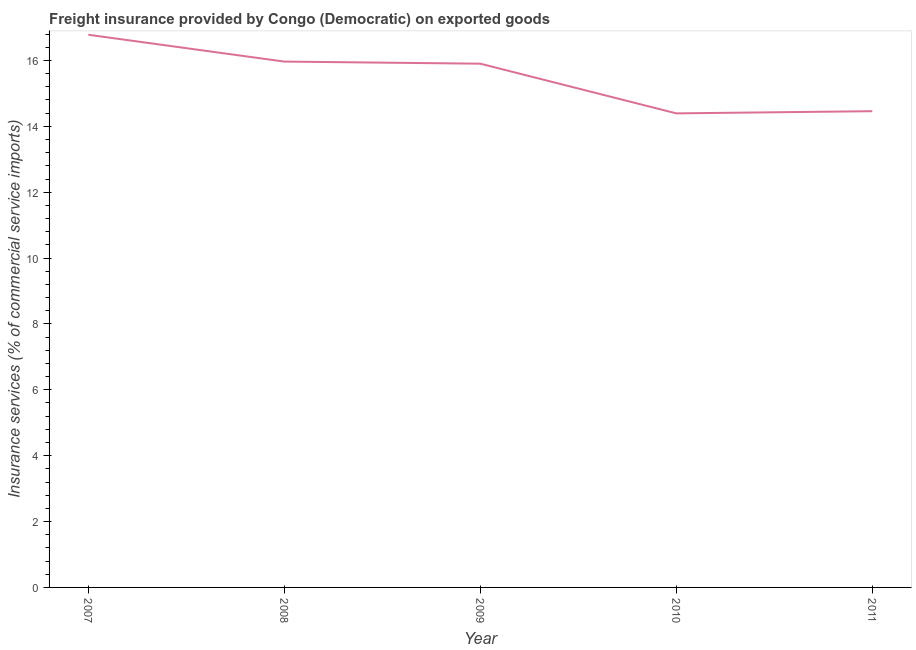What is the freight insurance in 2011?
Provide a succinct answer. 14.46. Across all years, what is the maximum freight insurance?
Offer a very short reply. 16.78. Across all years, what is the minimum freight insurance?
Give a very brief answer. 14.39. What is the sum of the freight insurance?
Your response must be concise. 77.5. What is the difference between the freight insurance in 2008 and 2009?
Offer a very short reply. 0.06. What is the average freight insurance per year?
Offer a terse response. 15.5. What is the median freight insurance?
Provide a succinct answer. 15.9. In how many years, is the freight insurance greater than 10.4 %?
Give a very brief answer. 5. What is the ratio of the freight insurance in 2009 to that in 2011?
Provide a succinct answer. 1.1. Is the freight insurance in 2007 less than that in 2010?
Ensure brevity in your answer.  No. What is the difference between the highest and the second highest freight insurance?
Provide a succinct answer. 0.81. Is the sum of the freight insurance in 2008 and 2009 greater than the maximum freight insurance across all years?
Keep it short and to the point. Yes. What is the difference between the highest and the lowest freight insurance?
Make the answer very short. 2.39. In how many years, is the freight insurance greater than the average freight insurance taken over all years?
Provide a short and direct response. 3. Does the freight insurance monotonically increase over the years?
Your response must be concise. No. How many lines are there?
Keep it short and to the point. 1. What is the title of the graph?
Offer a terse response. Freight insurance provided by Congo (Democratic) on exported goods . What is the label or title of the X-axis?
Keep it short and to the point. Year. What is the label or title of the Y-axis?
Give a very brief answer. Insurance services (% of commercial service imports). What is the Insurance services (% of commercial service imports) in 2007?
Give a very brief answer. 16.78. What is the Insurance services (% of commercial service imports) in 2008?
Provide a short and direct response. 15.97. What is the Insurance services (% of commercial service imports) in 2009?
Your response must be concise. 15.9. What is the Insurance services (% of commercial service imports) of 2010?
Keep it short and to the point. 14.39. What is the Insurance services (% of commercial service imports) of 2011?
Offer a very short reply. 14.46. What is the difference between the Insurance services (% of commercial service imports) in 2007 and 2008?
Your response must be concise. 0.81. What is the difference between the Insurance services (% of commercial service imports) in 2007 and 2009?
Your answer should be very brief. 0.88. What is the difference between the Insurance services (% of commercial service imports) in 2007 and 2010?
Provide a succinct answer. 2.39. What is the difference between the Insurance services (% of commercial service imports) in 2007 and 2011?
Ensure brevity in your answer.  2.32. What is the difference between the Insurance services (% of commercial service imports) in 2008 and 2009?
Keep it short and to the point. 0.06. What is the difference between the Insurance services (% of commercial service imports) in 2008 and 2010?
Your answer should be very brief. 1.57. What is the difference between the Insurance services (% of commercial service imports) in 2008 and 2011?
Your answer should be compact. 1.51. What is the difference between the Insurance services (% of commercial service imports) in 2009 and 2010?
Your answer should be very brief. 1.51. What is the difference between the Insurance services (% of commercial service imports) in 2009 and 2011?
Provide a short and direct response. 1.44. What is the difference between the Insurance services (% of commercial service imports) in 2010 and 2011?
Provide a short and direct response. -0.07. What is the ratio of the Insurance services (% of commercial service imports) in 2007 to that in 2008?
Your answer should be compact. 1.05. What is the ratio of the Insurance services (% of commercial service imports) in 2007 to that in 2009?
Give a very brief answer. 1.05. What is the ratio of the Insurance services (% of commercial service imports) in 2007 to that in 2010?
Offer a very short reply. 1.17. What is the ratio of the Insurance services (% of commercial service imports) in 2007 to that in 2011?
Your response must be concise. 1.16. What is the ratio of the Insurance services (% of commercial service imports) in 2008 to that in 2010?
Your response must be concise. 1.11. What is the ratio of the Insurance services (% of commercial service imports) in 2008 to that in 2011?
Your answer should be compact. 1.1. What is the ratio of the Insurance services (% of commercial service imports) in 2009 to that in 2010?
Provide a succinct answer. 1.1. What is the ratio of the Insurance services (% of commercial service imports) in 2010 to that in 2011?
Give a very brief answer. 0.99. 